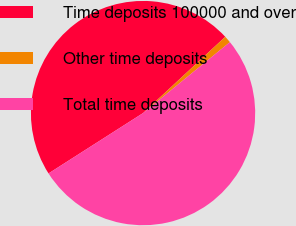<chart> <loc_0><loc_0><loc_500><loc_500><pie_chart><fcel>Time deposits 100000 and over<fcel>Other time deposits<fcel>Total time deposits<nl><fcel>47.14%<fcel>1.0%<fcel>51.86%<nl></chart> 